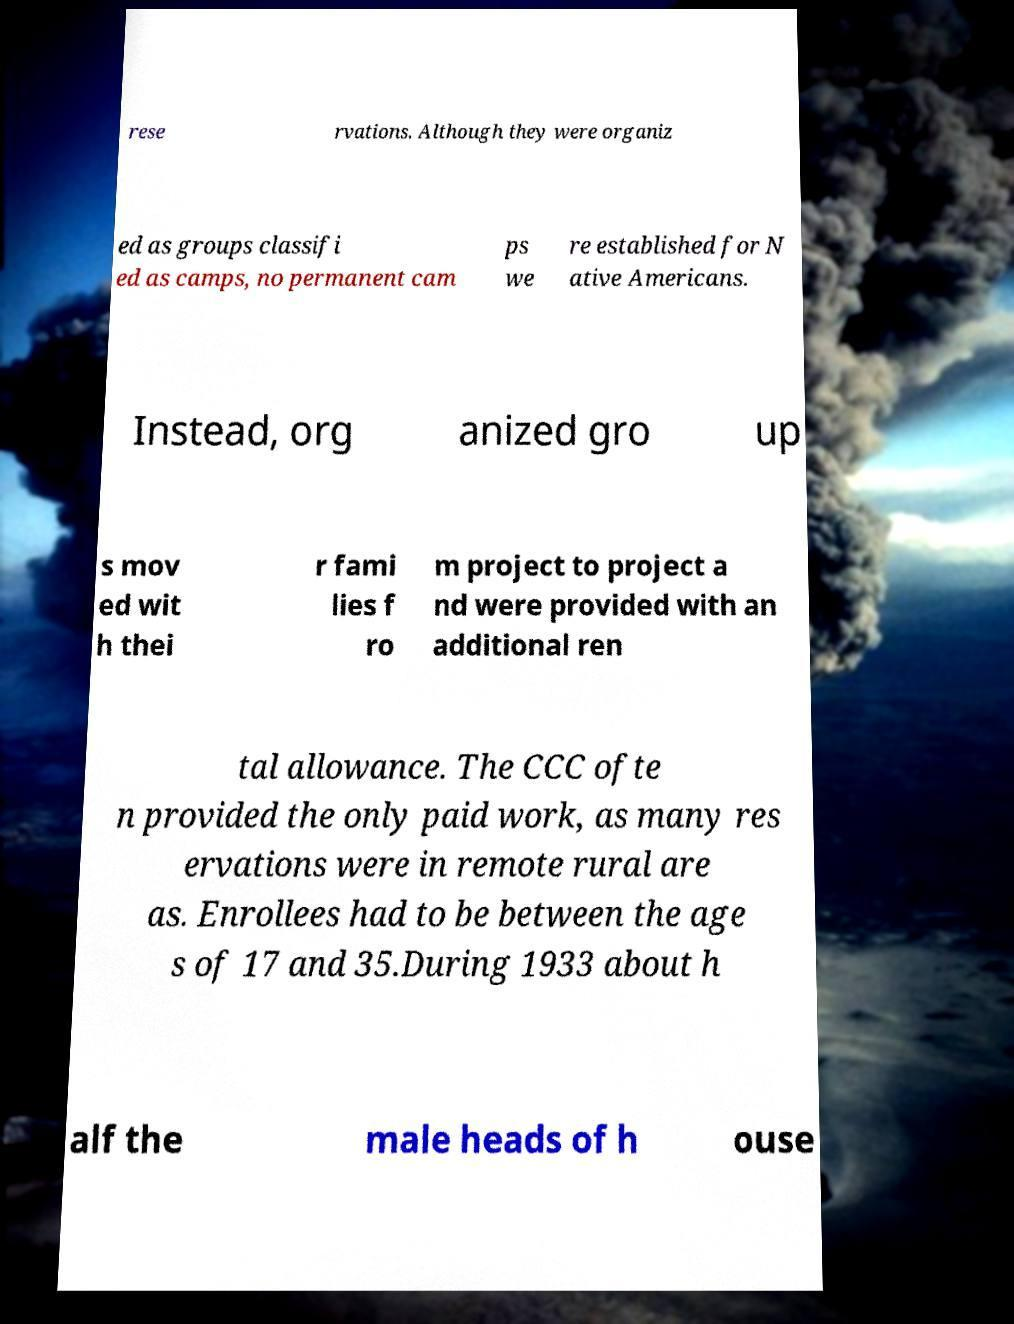For documentation purposes, I need the text within this image transcribed. Could you provide that? rese rvations. Although they were organiz ed as groups classifi ed as camps, no permanent cam ps we re established for N ative Americans. Instead, org anized gro up s mov ed wit h thei r fami lies f ro m project to project a nd were provided with an additional ren tal allowance. The CCC ofte n provided the only paid work, as many res ervations were in remote rural are as. Enrollees had to be between the age s of 17 and 35.During 1933 about h alf the male heads of h ouse 